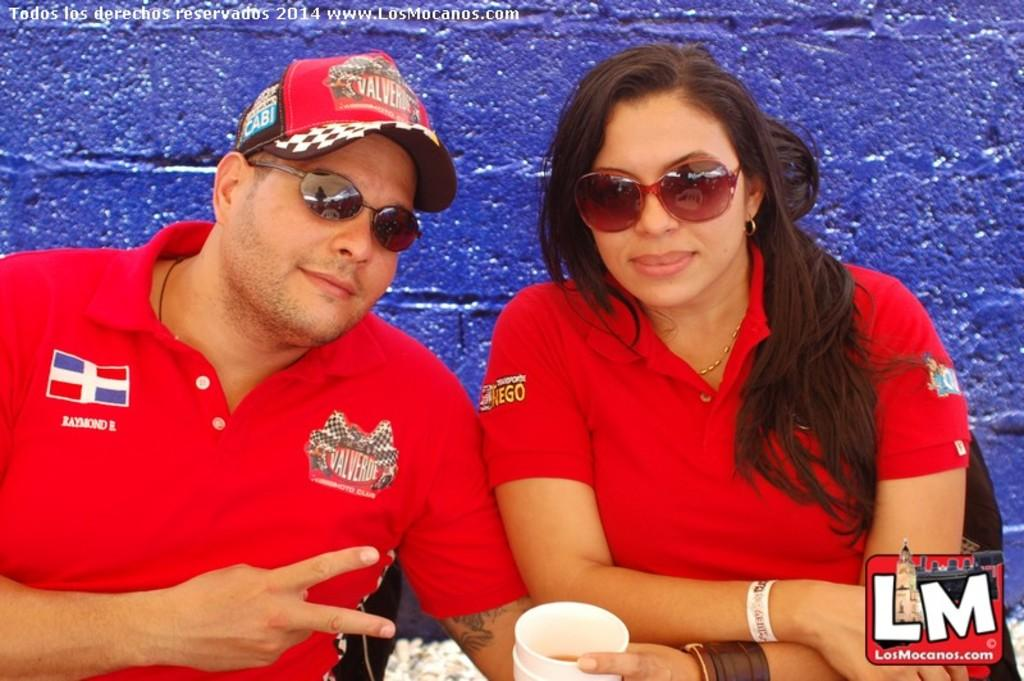Who is present in the image? There is a woman in the image. What is the woman holding in her hand? The woman is holding a glass in her hand. Can you describe the seating arrangement in the image? There is a person sitting on chairs in the image. What is visible at the top of the image? The top of the image includes a wall. What type of branch can be seen in the woman's hair in the image? There is no branch present in the woman's hair in the image. Does the woman have a tail in the image? No, the woman does not have a tail in the image. 